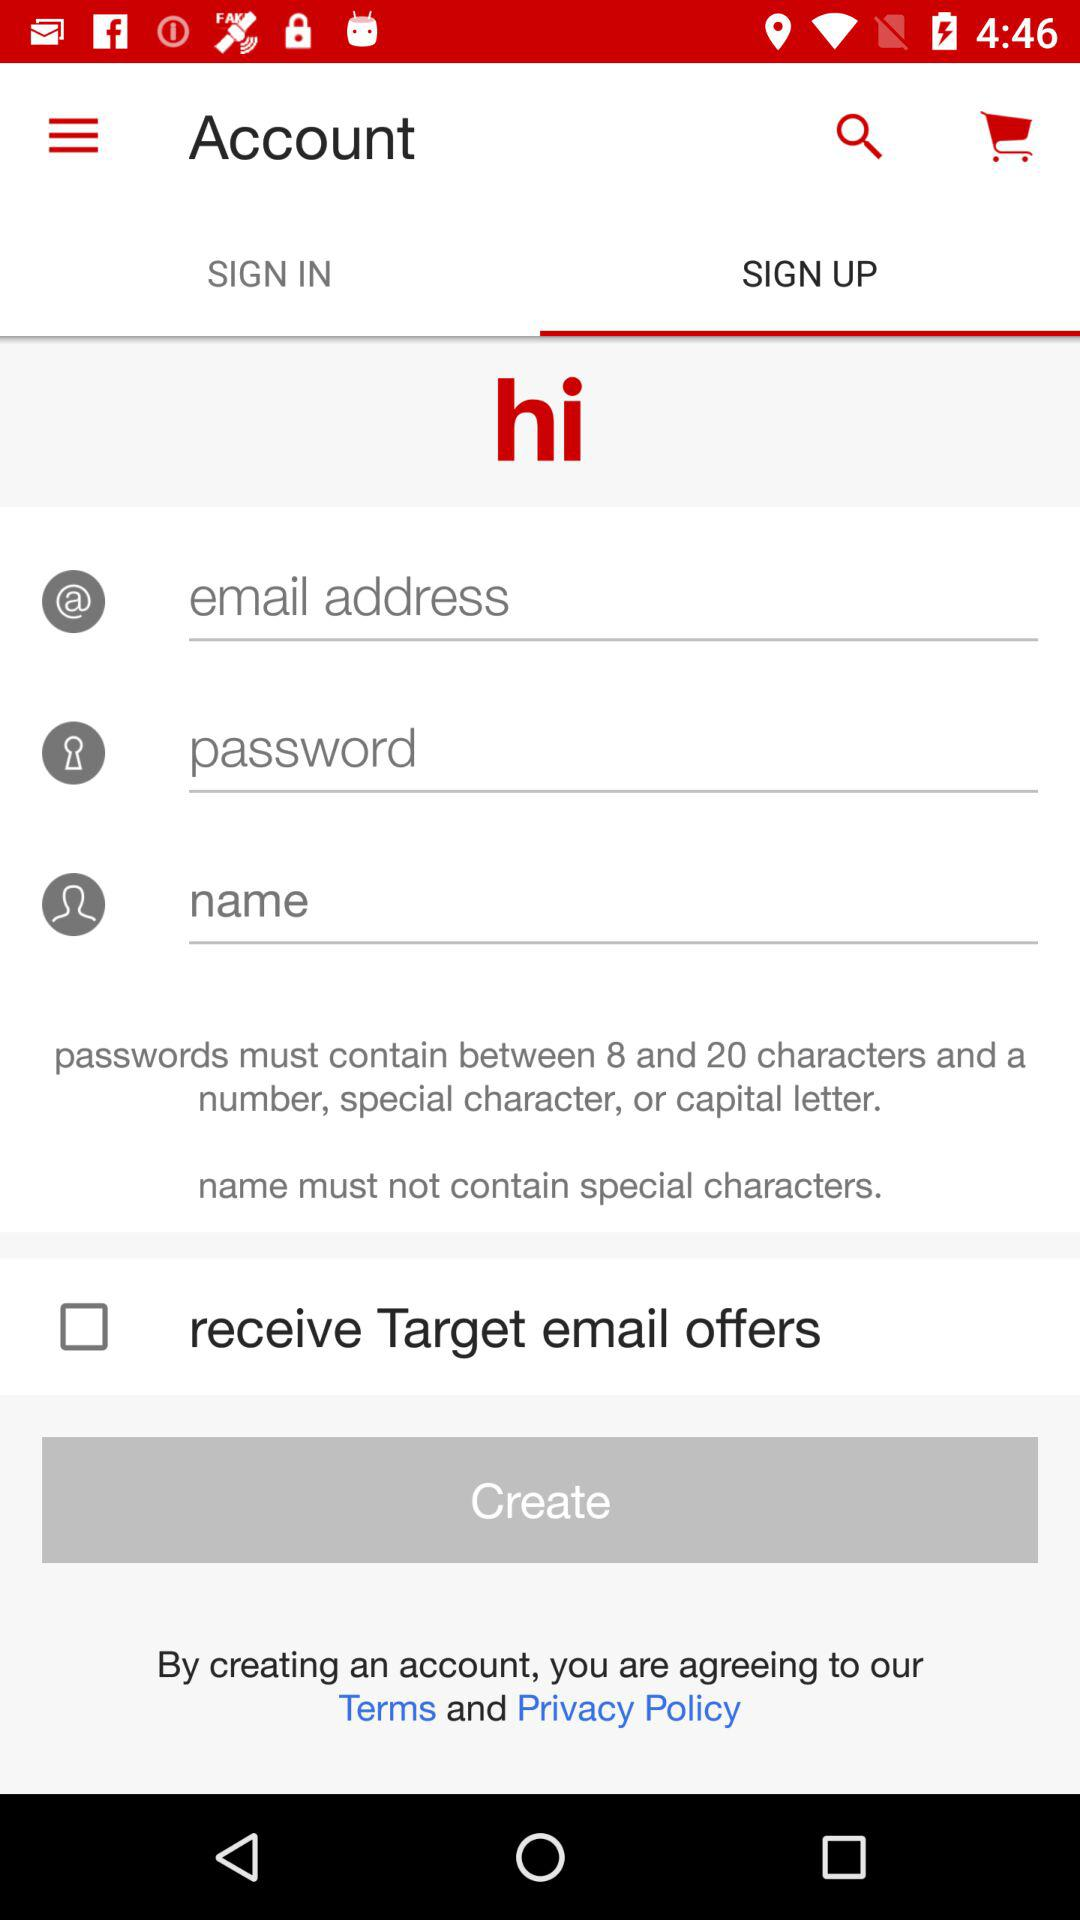What is the application name? The application name is "hi". 